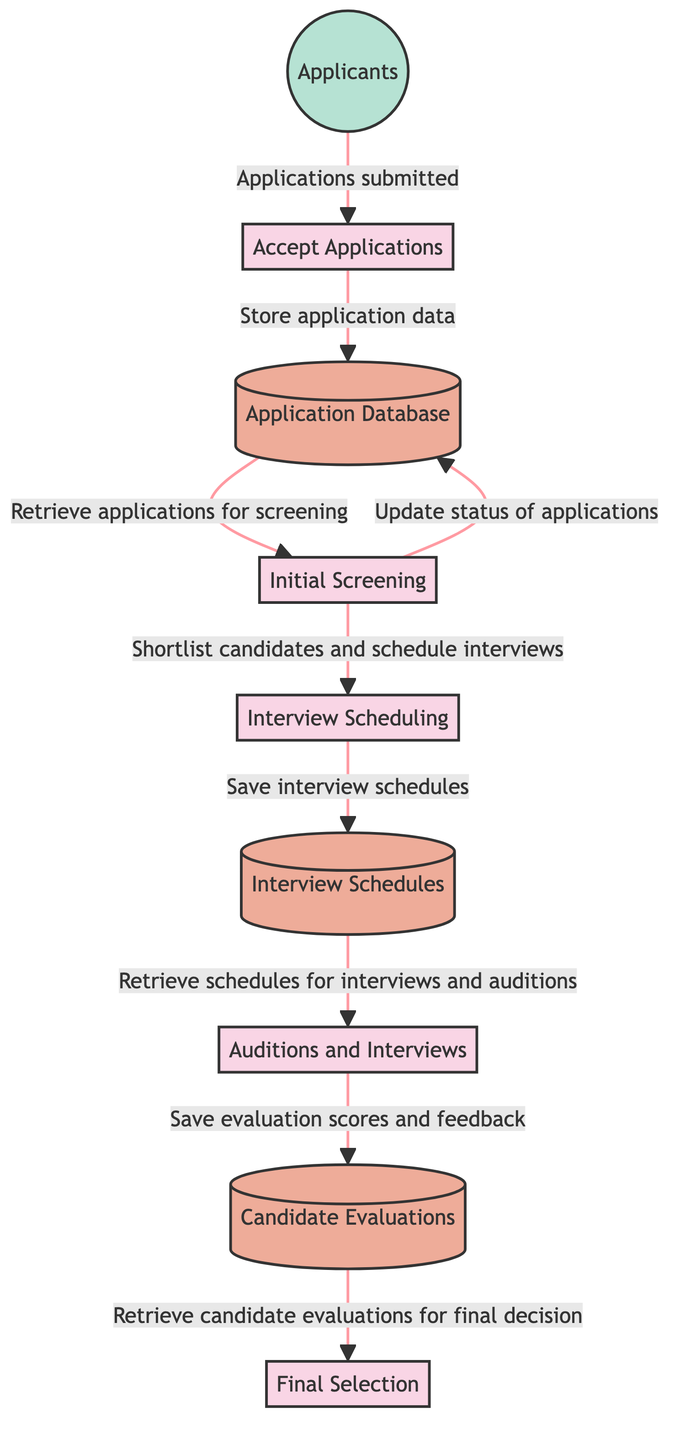What is the first process in the selection? The first process depicted in the diagram is "Accept Applications". This is indicated as the initial node after the external entity where applications are submitted.
Answer: Accept Applications How many data stores are there in the diagram? The diagram contains three data stores: "Application Database", "Interview Schedules", and "Candidate Evaluations". This can be counted directly from the nodes classified as data stores.
Answer: Three What does the "Initial Screening" process output? The "Initial Screening" process outputs two data flows: one updates the "Application Database" and the other goes to "Interview Scheduling" for shortlisting candidates.
Answer: Update status of applications & shortlist candidates Which external entity submits applications? The diagram clearly identifies the external entity as "Applicants", who submit their applications to the first process in the selection.
Answer: Applicants How many processes are involved in the selection process? According to the diagram, there are five distinct processes involved in the selection process: "Accept Applications", "Initial Screening", "Interview Scheduling", "Auditions and Interviews", and "Final Selection". This is derived from the labeled nodes classified as processes.
Answer: Five What is stored in the "Candidate Evaluations"? The "Candidate Evaluations" store contains evaluation scores and feedback coming from the auditions and interviews, specifically contributing to the final selection process. This is shown by the outgoing data flow from "Auditions and Interviews".
Answer: Evaluation scores and feedback Which process retrieves schedules for interviews and auditions? The process that retrieves schedules for interviews and auditions is "Auditions and Interviews". It receives schedules from the "Interview Schedules" data store, evidenced by a direct data flow connection.
Answer: Auditions and Interviews What action is taken after "Auditions and Interviews"? After "Auditions and Interviews", the action taken is storing evaluation scores and feedback in the "Candidate Evaluations" data store. This is indicated by the direction of data flow from "Auditions and Interviews" to "Candidate Evaluations".
Answer: Save evaluation scores and feedback What is the final output process of this selection flow? The final output process in this selection flow is "Final Selection". This indicates the concluding decision-making step based on all preceding evaluations.
Answer: Final Selection 